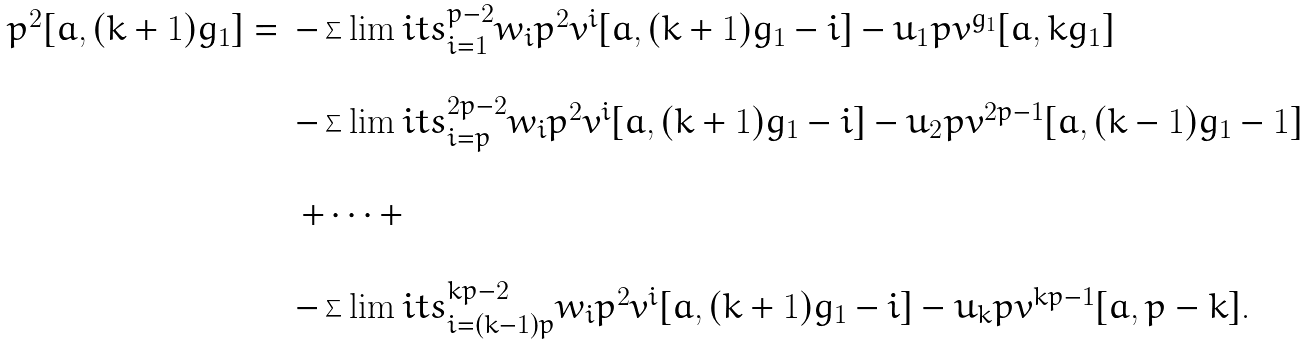Convert formula to latex. <formula><loc_0><loc_0><loc_500><loc_500>\begin{array} { r l } p ^ { 2 } [ a , ( k + 1 ) g _ { 1 } ] = & - \sum \lim i t s _ { i = 1 } ^ { p - 2 } w _ { i } p ^ { 2 } v ^ { i } [ a , ( k + 1 ) g _ { 1 } - i ] - u _ { 1 } p v ^ { g _ { 1 } } [ a , k g _ { 1 } ] \\ \\ & - \sum \lim i t s _ { i = p } ^ { 2 p - 2 } w _ { i } p ^ { 2 } v ^ { i } [ a , ( k + 1 ) g _ { 1 } - i ] - u _ { 2 } p v ^ { 2 p - 1 } [ a , ( k - 1 ) g _ { 1 } - 1 ] \\ \\ & \, + \cdots + \\ \\ & - \sum \lim i t s _ { i = ( k - 1 ) p } ^ { k p - 2 } w _ { i } p ^ { 2 } v ^ { i } [ a , ( k + 1 ) g _ { 1 } - i ] - u _ { k } p v ^ { k p - 1 } [ a , p - k ] . \end{array}</formula> 